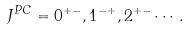<formula> <loc_0><loc_0><loc_500><loc_500>J ^ { P C } = 0 ^ { + - } , 1 ^ { - + } , 2 ^ { + - } \cdots .</formula> 